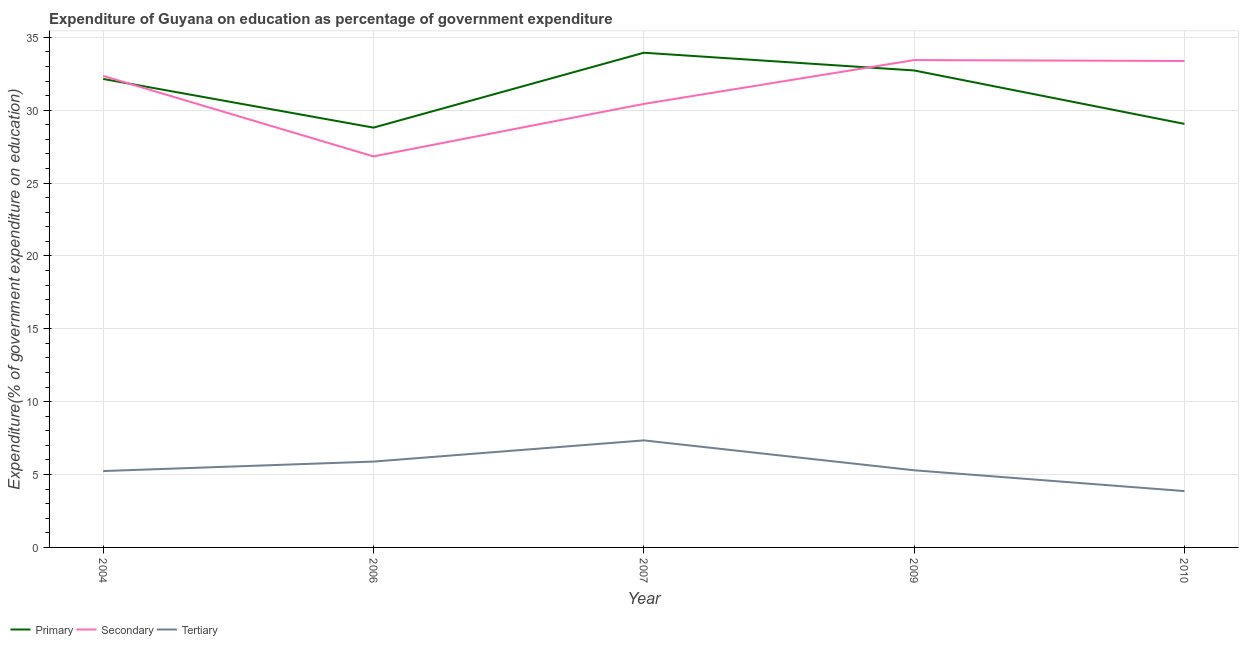How many different coloured lines are there?
Your answer should be very brief. 3. What is the expenditure on secondary education in 2009?
Your answer should be compact. 33.44. Across all years, what is the maximum expenditure on primary education?
Give a very brief answer. 33.94. Across all years, what is the minimum expenditure on tertiary education?
Keep it short and to the point. 3.87. What is the total expenditure on primary education in the graph?
Offer a terse response. 156.68. What is the difference between the expenditure on primary education in 2004 and that in 2007?
Ensure brevity in your answer.  -1.8. What is the difference between the expenditure on primary education in 2007 and the expenditure on secondary education in 2009?
Keep it short and to the point. 0.5. What is the average expenditure on tertiary education per year?
Offer a terse response. 5.53. In the year 2004, what is the difference between the expenditure on primary education and expenditure on tertiary education?
Ensure brevity in your answer.  26.9. In how many years, is the expenditure on secondary education greater than 3 %?
Ensure brevity in your answer.  5. What is the ratio of the expenditure on tertiary education in 2006 to that in 2007?
Ensure brevity in your answer.  0.8. Is the expenditure on secondary education in 2004 less than that in 2010?
Your response must be concise. Yes. What is the difference between the highest and the second highest expenditure on primary education?
Keep it short and to the point. 1.21. What is the difference between the highest and the lowest expenditure on tertiary education?
Provide a short and direct response. 3.48. Is the expenditure on primary education strictly less than the expenditure on tertiary education over the years?
Your answer should be very brief. No. How many lines are there?
Keep it short and to the point. 3. What is the difference between two consecutive major ticks on the Y-axis?
Give a very brief answer. 5. Does the graph contain grids?
Ensure brevity in your answer.  Yes. Where does the legend appear in the graph?
Keep it short and to the point. Bottom left. How are the legend labels stacked?
Provide a succinct answer. Horizontal. What is the title of the graph?
Ensure brevity in your answer.  Expenditure of Guyana on education as percentage of government expenditure. Does "Oil sources" appear as one of the legend labels in the graph?
Offer a terse response. No. What is the label or title of the Y-axis?
Offer a terse response. Expenditure(% of government expenditure on education). What is the Expenditure(% of government expenditure on education) in Primary in 2004?
Ensure brevity in your answer.  32.14. What is the Expenditure(% of government expenditure on education) in Secondary in 2004?
Provide a short and direct response. 32.35. What is the Expenditure(% of government expenditure on education) of Tertiary in 2004?
Give a very brief answer. 5.24. What is the Expenditure(% of government expenditure on education) of Primary in 2006?
Keep it short and to the point. 28.8. What is the Expenditure(% of government expenditure on education) of Secondary in 2006?
Provide a short and direct response. 26.83. What is the Expenditure(% of government expenditure on education) in Tertiary in 2006?
Provide a short and direct response. 5.89. What is the Expenditure(% of government expenditure on education) in Primary in 2007?
Your answer should be very brief. 33.94. What is the Expenditure(% of government expenditure on education) of Secondary in 2007?
Ensure brevity in your answer.  30.43. What is the Expenditure(% of government expenditure on education) of Tertiary in 2007?
Make the answer very short. 7.34. What is the Expenditure(% of government expenditure on education) in Primary in 2009?
Offer a terse response. 32.73. What is the Expenditure(% of government expenditure on education) of Secondary in 2009?
Provide a short and direct response. 33.44. What is the Expenditure(% of government expenditure on education) in Tertiary in 2009?
Offer a terse response. 5.29. What is the Expenditure(% of government expenditure on education) in Primary in 2010?
Ensure brevity in your answer.  29.06. What is the Expenditure(% of government expenditure on education) in Secondary in 2010?
Ensure brevity in your answer.  33.38. What is the Expenditure(% of government expenditure on education) of Tertiary in 2010?
Provide a short and direct response. 3.87. Across all years, what is the maximum Expenditure(% of government expenditure on education) in Primary?
Make the answer very short. 33.94. Across all years, what is the maximum Expenditure(% of government expenditure on education) in Secondary?
Provide a short and direct response. 33.44. Across all years, what is the maximum Expenditure(% of government expenditure on education) in Tertiary?
Offer a very short reply. 7.34. Across all years, what is the minimum Expenditure(% of government expenditure on education) of Primary?
Your answer should be very brief. 28.8. Across all years, what is the minimum Expenditure(% of government expenditure on education) in Secondary?
Ensure brevity in your answer.  26.83. Across all years, what is the minimum Expenditure(% of government expenditure on education) in Tertiary?
Your answer should be very brief. 3.87. What is the total Expenditure(% of government expenditure on education) of Primary in the graph?
Your answer should be very brief. 156.68. What is the total Expenditure(% of government expenditure on education) in Secondary in the graph?
Offer a very short reply. 156.43. What is the total Expenditure(% of government expenditure on education) of Tertiary in the graph?
Your response must be concise. 27.63. What is the difference between the Expenditure(% of government expenditure on education) in Primary in 2004 and that in 2006?
Offer a very short reply. 3.34. What is the difference between the Expenditure(% of government expenditure on education) in Secondary in 2004 and that in 2006?
Ensure brevity in your answer.  5.52. What is the difference between the Expenditure(% of government expenditure on education) in Tertiary in 2004 and that in 2006?
Your response must be concise. -0.65. What is the difference between the Expenditure(% of government expenditure on education) of Primary in 2004 and that in 2007?
Offer a very short reply. -1.8. What is the difference between the Expenditure(% of government expenditure on education) of Secondary in 2004 and that in 2007?
Your response must be concise. 1.92. What is the difference between the Expenditure(% of government expenditure on education) in Tertiary in 2004 and that in 2007?
Provide a short and direct response. -2.1. What is the difference between the Expenditure(% of government expenditure on education) of Primary in 2004 and that in 2009?
Give a very brief answer. -0.58. What is the difference between the Expenditure(% of government expenditure on education) of Secondary in 2004 and that in 2009?
Your answer should be very brief. -1.09. What is the difference between the Expenditure(% of government expenditure on education) of Tertiary in 2004 and that in 2009?
Your answer should be very brief. -0.05. What is the difference between the Expenditure(% of government expenditure on education) of Primary in 2004 and that in 2010?
Your answer should be very brief. 3.08. What is the difference between the Expenditure(% of government expenditure on education) of Secondary in 2004 and that in 2010?
Offer a very short reply. -1.02. What is the difference between the Expenditure(% of government expenditure on education) in Tertiary in 2004 and that in 2010?
Give a very brief answer. 1.37. What is the difference between the Expenditure(% of government expenditure on education) of Primary in 2006 and that in 2007?
Keep it short and to the point. -5.14. What is the difference between the Expenditure(% of government expenditure on education) of Secondary in 2006 and that in 2007?
Keep it short and to the point. -3.6. What is the difference between the Expenditure(% of government expenditure on education) in Tertiary in 2006 and that in 2007?
Offer a very short reply. -1.45. What is the difference between the Expenditure(% of government expenditure on education) in Primary in 2006 and that in 2009?
Offer a very short reply. -3.92. What is the difference between the Expenditure(% of government expenditure on education) in Secondary in 2006 and that in 2009?
Your answer should be very brief. -6.61. What is the difference between the Expenditure(% of government expenditure on education) of Tertiary in 2006 and that in 2009?
Provide a succinct answer. 0.6. What is the difference between the Expenditure(% of government expenditure on education) of Primary in 2006 and that in 2010?
Offer a very short reply. -0.26. What is the difference between the Expenditure(% of government expenditure on education) of Secondary in 2006 and that in 2010?
Your response must be concise. -6.55. What is the difference between the Expenditure(% of government expenditure on education) of Tertiary in 2006 and that in 2010?
Your response must be concise. 2.02. What is the difference between the Expenditure(% of government expenditure on education) of Primary in 2007 and that in 2009?
Offer a very short reply. 1.22. What is the difference between the Expenditure(% of government expenditure on education) of Secondary in 2007 and that in 2009?
Your answer should be very brief. -3.01. What is the difference between the Expenditure(% of government expenditure on education) in Tertiary in 2007 and that in 2009?
Provide a short and direct response. 2.05. What is the difference between the Expenditure(% of government expenditure on education) of Primary in 2007 and that in 2010?
Give a very brief answer. 4.88. What is the difference between the Expenditure(% of government expenditure on education) of Secondary in 2007 and that in 2010?
Offer a very short reply. -2.95. What is the difference between the Expenditure(% of government expenditure on education) of Tertiary in 2007 and that in 2010?
Keep it short and to the point. 3.48. What is the difference between the Expenditure(% of government expenditure on education) in Primary in 2009 and that in 2010?
Your answer should be very brief. 3.67. What is the difference between the Expenditure(% of government expenditure on education) of Secondary in 2009 and that in 2010?
Make the answer very short. 0.06. What is the difference between the Expenditure(% of government expenditure on education) of Tertiary in 2009 and that in 2010?
Offer a very short reply. 1.43. What is the difference between the Expenditure(% of government expenditure on education) of Primary in 2004 and the Expenditure(% of government expenditure on education) of Secondary in 2006?
Offer a very short reply. 5.31. What is the difference between the Expenditure(% of government expenditure on education) of Primary in 2004 and the Expenditure(% of government expenditure on education) of Tertiary in 2006?
Provide a succinct answer. 26.25. What is the difference between the Expenditure(% of government expenditure on education) in Secondary in 2004 and the Expenditure(% of government expenditure on education) in Tertiary in 2006?
Ensure brevity in your answer.  26.46. What is the difference between the Expenditure(% of government expenditure on education) in Primary in 2004 and the Expenditure(% of government expenditure on education) in Secondary in 2007?
Ensure brevity in your answer.  1.71. What is the difference between the Expenditure(% of government expenditure on education) of Primary in 2004 and the Expenditure(% of government expenditure on education) of Tertiary in 2007?
Make the answer very short. 24.8. What is the difference between the Expenditure(% of government expenditure on education) in Secondary in 2004 and the Expenditure(% of government expenditure on education) in Tertiary in 2007?
Keep it short and to the point. 25.01. What is the difference between the Expenditure(% of government expenditure on education) of Primary in 2004 and the Expenditure(% of government expenditure on education) of Secondary in 2009?
Offer a very short reply. -1.3. What is the difference between the Expenditure(% of government expenditure on education) of Primary in 2004 and the Expenditure(% of government expenditure on education) of Tertiary in 2009?
Offer a terse response. 26.85. What is the difference between the Expenditure(% of government expenditure on education) in Secondary in 2004 and the Expenditure(% of government expenditure on education) in Tertiary in 2009?
Your answer should be compact. 27.06. What is the difference between the Expenditure(% of government expenditure on education) in Primary in 2004 and the Expenditure(% of government expenditure on education) in Secondary in 2010?
Your answer should be compact. -1.23. What is the difference between the Expenditure(% of government expenditure on education) in Primary in 2004 and the Expenditure(% of government expenditure on education) in Tertiary in 2010?
Keep it short and to the point. 28.28. What is the difference between the Expenditure(% of government expenditure on education) in Secondary in 2004 and the Expenditure(% of government expenditure on education) in Tertiary in 2010?
Give a very brief answer. 28.49. What is the difference between the Expenditure(% of government expenditure on education) in Primary in 2006 and the Expenditure(% of government expenditure on education) in Secondary in 2007?
Provide a short and direct response. -1.63. What is the difference between the Expenditure(% of government expenditure on education) of Primary in 2006 and the Expenditure(% of government expenditure on education) of Tertiary in 2007?
Keep it short and to the point. 21.46. What is the difference between the Expenditure(% of government expenditure on education) of Secondary in 2006 and the Expenditure(% of government expenditure on education) of Tertiary in 2007?
Your response must be concise. 19.49. What is the difference between the Expenditure(% of government expenditure on education) in Primary in 2006 and the Expenditure(% of government expenditure on education) in Secondary in 2009?
Your response must be concise. -4.63. What is the difference between the Expenditure(% of government expenditure on education) in Primary in 2006 and the Expenditure(% of government expenditure on education) in Tertiary in 2009?
Keep it short and to the point. 23.51. What is the difference between the Expenditure(% of government expenditure on education) of Secondary in 2006 and the Expenditure(% of government expenditure on education) of Tertiary in 2009?
Ensure brevity in your answer.  21.54. What is the difference between the Expenditure(% of government expenditure on education) in Primary in 2006 and the Expenditure(% of government expenditure on education) in Secondary in 2010?
Provide a succinct answer. -4.57. What is the difference between the Expenditure(% of government expenditure on education) of Primary in 2006 and the Expenditure(% of government expenditure on education) of Tertiary in 2010?
Your answer should be compact. 24.94. What is the difference between the Expenditure(% of government expenditure on education) in Secondary in 2006 and the Expenditure(% of government expenditure on education) in Tertiary in 2010?
Your answer should be compact. 22.96. What is the difference between the Expenditure(% of government expenditure on education) of Primary in 2007 and the Expenditure(% of government expenditure on education) of Secondary in 2009?
Your response must be concise. 0.5. What is the difference between the Expenditure(% of government expenditure on education) of Primary in 2007 and the Expenditure(% of government expenditure on education) of Tertiary in 2009?
Your answer should be very brief. 28.65. What is the difference between the Expenditure(% of government expenditure on education) in Secondary in 2007 and the Expenditure(% of government expenditure on education) in Tertiary in 2009?
Provide a succinct answer. 25.14. What is the difference between the Expenditure(% of government expenditure on education) in Primary in 2007 and the Expenditure(% of government expenditure on education) in Secondary in 2010?
Ensure brevity in your answer.  0.56. What is the difference between the Expenditure(% of government expenditure on education) in Primary in 2007 and the Expenditure(% of government expenditure on education) in Tertiary in 2010?
Your response must be concise. 30.08. What is the difference between the Expenditure(% of government expenditure on education) in Secondary in 2007 and the Expenditure(% of government expenditure on education) in Tertiary in 2010?
Provide a succinct answer. 26.57. What is the difference between the Expenditure(% of government expenditure on education) in Primary in 2009 and the Expenditure(% of government expenditure on education) in Secondary in 2010?
Provide a short and direct response. -0.65. What is the difference between the Expenditure(% of government expenditure on education) in Primary in 2009 and the Expenditure(% of government expenditure on education) in Tertiary in 2010?
Your answer should be very brief. 28.86. What is the difference between the Expenditure(% of government expenditure on education) in Secondary in 2009 and the Expenditure(% of government expenditure on education) in Tertiary in 2010?
Make the answer very short. 29.57. What is the average Expenditure(% of government expenditure on education) in Primary per year?
Make the answer very short. 31.34. What is the average Expenditure(% of government expenditure on education) in Secondary per year?
Keep it short and to the point. 31.29. What is the average Expenditure(% of government expenditure on education) in Tertiary per year?
Your answer should be very brief. 5.53. In the year 2004, what is the difference between the Expenditure(% of government expenditure on education) in Primary and Expenditure(% of government expenditure on education) in Secondary?
Your response must be concise. -0.21. In the year 2004, what is the difference between the Expenditure(% of government expenditure on education) in Primary and Expenditure(% of government expenditure on education) in Tertiary?
Offer a very short reply. 26.9. In the year 2004, what is the difference between the Expenditure(% of government expenditure on education) of Secondary and Expenditure(% of government expenditure on education) of Tertiary?
Give a very brief answer. 27.11. In the year 2006, what is the difference between the Expenditure(% of government expenditure on education) of Primary and Expenditure(% of government expenditure on education) of Secondary?
Keep it short and to the point. 1.97. In the year 2006, what is the difference between the Expenditure(% of government expenditure on education) in Primary and Expenditure(% of government expenditure on education) in Tertiary?
Offer a terse response. 22.91. In the year 2006, what is the difference between the Expenditure(% of government expenditure on education) of Secondary and Expenditure(% of government expenditure on education) of Tertiary?
Give a very brief answer. 20.94. In the year 2007, what is the difference between the Expenditure(% of government expenditure on education) of Primary and Expenditure(% of government expenditure on education) of Secondary?
Offer a terse response. 3.51. In the year 2007, what is the difference between the Expenditure(% of government expenditure on education) of Primary and Expenditure(% of government expenditure on education) of Tertiary?
Your answer should be very brief. 26.6. In the year 2007, what is the difference between the Expenditure(% of government expenditure on education) of Secondary and Expenditure(% of government expenditure on education) of Tertiary?
Your response must be concise. 23.09. In the year 2009, what is the difference between the Expenditure(% of government expenditure on education) of Primary and Expenditure(% of government expenditure on education) of Secondary?
Keep it short and to the point. -0.71. In the year 2009, what is the difference between the Expenditure(% of government expenditure on education) of Primary and Expenditure(% of government expenditure on education) of Tertiary?
Your response must be concise. 27.43. In the year 2009, what is the difference between the Expenditure(% of government expenditure on education) in Secondary and Expenditure(% of government expenditure on education) in Tertiary?
Provide a succinct answer. 28.15. In the year 2010, what is the difference between the Expenditure(% of government expenditure on education) in Primary and Expenditure(% of government expenditure on education) in Secondary?
Offer a very short reply. -4.32. In the year 2010, what is the difference between the Expenditure(% of government expenditure on education) in Primary and Expenditure(% of government expenditure on education) in Tertiary?
Offer a terse response. 25.19. In the year 2010, what is the difference between the Expenditure(% of government expenditure on education) in Secondary and Expenditure(% of government expenditure on education) in Tertiary?
Ensure brevity in your answer.  29.51. What is the ratio of the Expenditure(% of government expenditure on education) of Primary in 2004 to that in 2006?
Your answer should be very brief. 1.12. What is the ratio of the Expenditure(% of government expenditure on education) of Secondary in 2004 to that in 2006?
Your answer should be compact. 1.21. What is the ratio of the Expenditure(% of government expenditure on education) in Tertiary in 2004 to that in 2006?
Provide a succinct answer. 0.89. What is the ratio of the Expenditure(% of government expenditure on education) in Primary in 2004 to that in 2007?
Offer a very short reply. 0.95. What is the ratio of the Expenditure(% of government expenditure on education) of Secondary in 2004 to that in 2007?
Your answer should be very brief. 1.06. What is the ratio of the Expenditure(% of government expenditure on education) in Tertiary in 2004 to that in 2007?
Offer a very short reply. 0.71. What is the ratio of the Expenditure(% of government expenditure on education) in Primary in 2004 to that in 2009?
Keep it short and to the point. 0.98. What is the ratio of the Expenditure(% of government expenditure on education) in Secondary in 2004 to that in 2009?
Give a very brief answer. 0.97. What is the ratio of the Expenditure(% of government expenditure on education) of Primary in 2004 to that in 2010?
Give a very brief answer. 1.11. What is the ratio of the Expenditure(% of government expenditure on education) of Secondary in 2004 to that in 2010?
Provide a succinct answer. 0.97. What is the ratio of the Expenditure(% of government expenditure on education) in Tertiary in 2004 to that in 2010?
Your answer should be compact. 1.36. What is the ratio of the Expenditure(% of government expenditure on education) in Primary in 2006 to that in 2007?
Your answer should be compact. 0.85. What is the ratio of the Expenditure(% of government expenditure on education) of Secondary in 2006 to that in 2007?
Keep it short and to the point. 0.88. What is the ratio of the Expenditure(% of government expenditure on education) of Tertiary in 2006 to that in 2007?
Make the answer very short. 0.8. What is the ratio of the Expenditure(% of government expenditure on education) of Primary in 2006 to that in 2009?
Give a very brief answer. 0.88. What is the ratio of the Expenditure(% of government expenditure on education) in Secondary in 2006 to that in 2009?
Provide a short and direct response. 0.8. What is the ratio of the Expenditure(% of government expenditure on education) of Tertiary in 2006 to that in 2009?
Make the answer very short. 1.11. What is the ratio of the Expenditure(% of government expenditure on education) of Primary in 2006 to that in 2010?
Give a very brief answer. 0.99. What is the ratio of the Expenditure(% of government expenditure on education) of Secondary in 2006 to that in 2010?
Your answer should be very brief. 0.8. What is the ratio of the Expenditure(% of government expenditure on education) of Tertiary in 2006 to that in 2010?
Provide a succinct answer. 1.52. What is the ratio of the Expenditure(% of government expenditure on education) in Primary in 2007 to that in 2009?
Keep it short and to the point. 1.04. What is the ratio of the Expenditure(% of government expenditure on education) in Secondary in 2007 to that in 2009?
Provide a short and direct response. 0.91. What is the ratio of the Expenditure(% of government expenditure on education) in Tertiary in 2007 to that in 2009?
Make the answer very short. 1.39. What is the ratio of the Expenditure(% of government expenditure on education) in Primary in 2007 to that in 2010?
Ensure brevity in your answer.  1.17. What is the ratio of the Expenditure(% of government expenditure on education) of Secondary in 2007 to that in 2010?
Offer a very short reply. 0.91. What is the ratio of the Expenditure(% of government expenditure on education) in Tertiary in 2007 to that in 2010?
Your answer should be compact. 1.9. What is the ratio of the Expenditure(% of government expenditure on education) in Primary in 2009 to that in 2010?
Offer a terse response. 1.13. What is the ratio of the Expenditure(% of government expenditure on education) of Secondary in 2009 to that in 2010?
Offer a very short reply. 1. What is the ratio of the Expenditure(% of government expenditure on education) in Tertiary in 2009 to that in 2010?
Keep it short and to the point. 1.37. What is the difference between the highest and the second highest Expenditure(% of government expenditure on education) in Primary?
Provide a succinct answer. 1.22. What is the difference between the highest and the second highest Expenditure(% of government expenditure on education) in Secondary?
Provide a short and direct response. 0.06. What is the difference between the highest and the second highest Expenditure(% of government expenditure on education) of Tertiary?
Your answer should be compact. 1.45. What is the difference between the highest and the lowest Expenditure(% of government expenditure on education) of Primary?
Your answer should be very brief. 5.14. What is the difference between the highest and the lowest Expenditure(% of government expenditure on education) in Secondary?
Your answer should be compact. 6.61. What is the difference between the highest and the lowest Expenditure(% of government expenditure on education) of Tertiary?
Give a very brief answer. 3.48. 